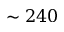Convert formula to latex. <formula><loc_0><loc_0><loc_500><loc_500>\sim 2 4 0</formula> 